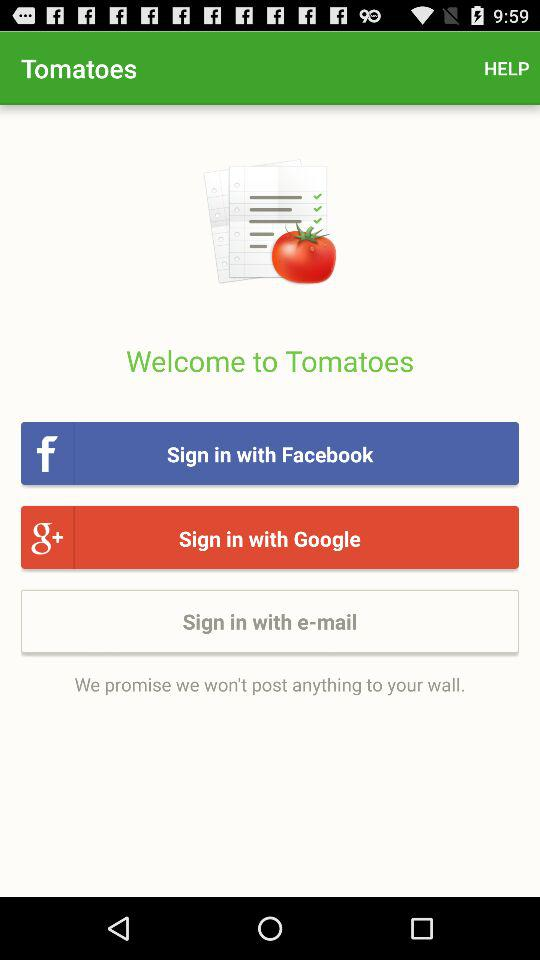How many sign-in options are there?
Answer the question using a single word or phrase. 3 